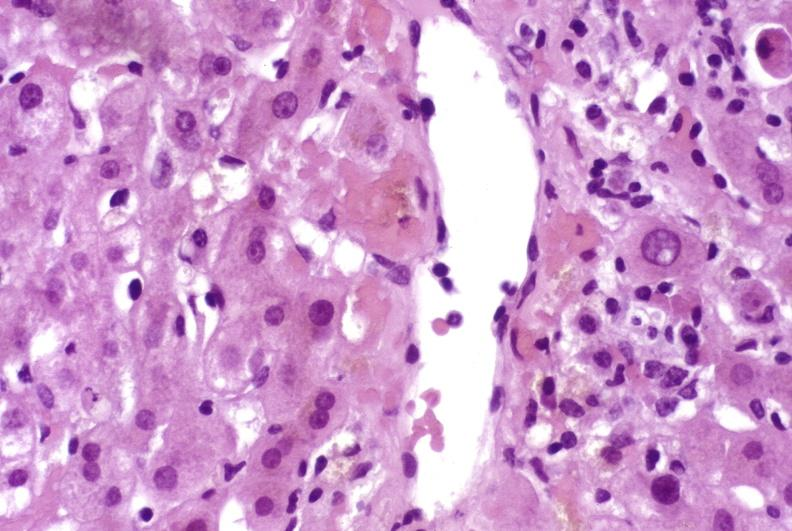what does this image show?
Answer the question using a single word or phrase. Mild acute rejection 